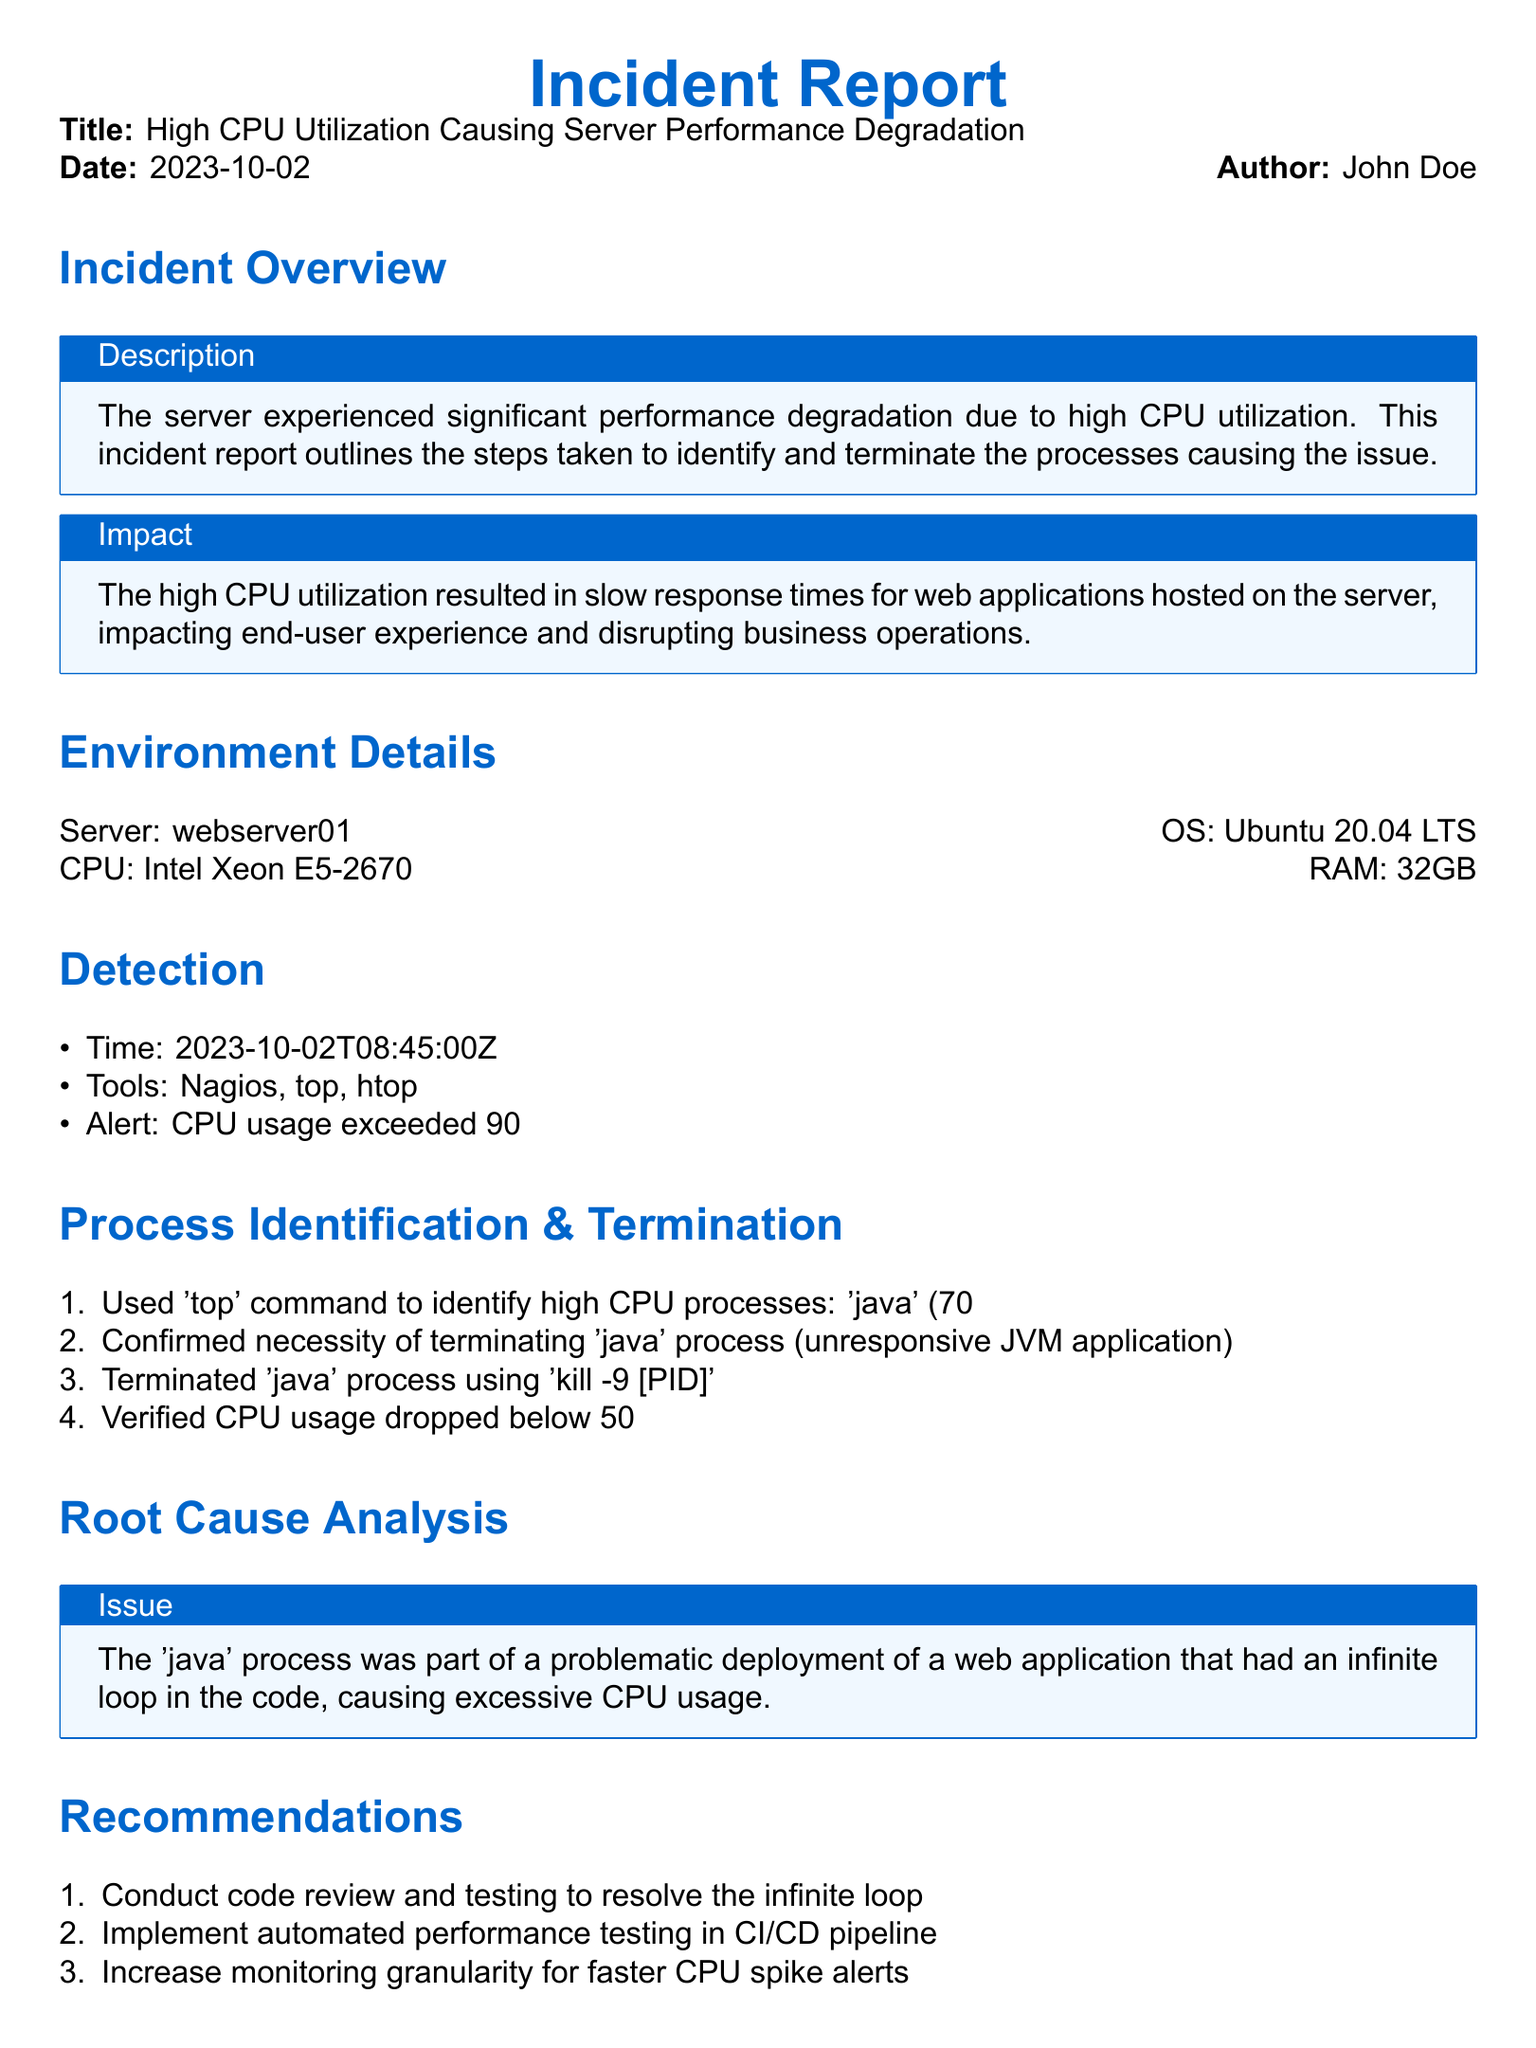What was the date of the incident? The date of the incident is provided at the beginning of the document.
Answer: 2023-10-02 Who authored the incident report? The name of the author is mentioned in the document's header section.
Answer: John Doe What server was involved in the incident? The specific server name is stated alongside the OS details in the document.
Answer: webserver01 What was the CPU utilization percentage when the alert was triggered? The document specifies the CPU usage threshold that triggered the alert.
Answer: 90% What process was consuming the highest CPU? The name of the process causing the most CPU consumption is listed in the process identification section.
Answer: java What command was used to terminate the problematic process? The specific command for terminating the process is mentioned in the Process Identification & Termination section.
Answer: kill -9 What was the root cause of the high CPU utilization? The document describes the underlying issue that led to the incident.
Answer: Infinite loop What recommendation was made to resolve the root cause? One of the recommendations addresses the need for addressing the underlying code issue.
Answer: Conduct code review How was CPU usage verified post-termination? The document mentions the verification method used after terminating the process.
Answer: Verified CPU usage dropped below 50% What next step was planned after the incident? The document outlines a follow-up action item regarding team communication post-incident.
Answer: Schedule team meeting for post-incident review 